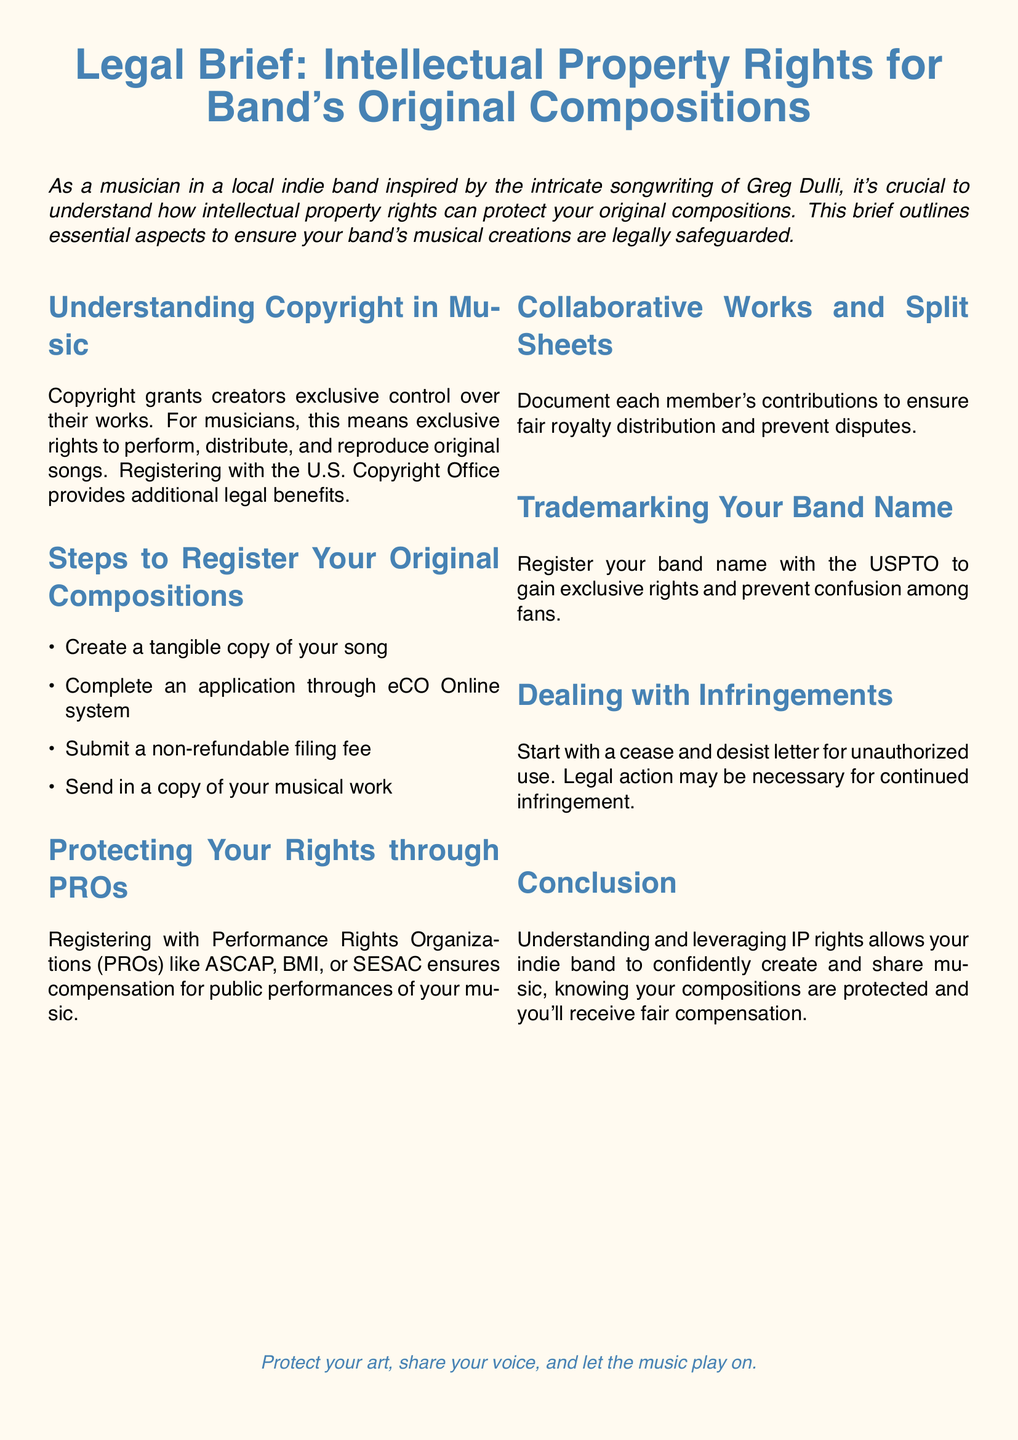What is the title of the legal brief? The title is the main heading of the document and indicates the subject matter.
Answer: Legal Brief: Intellectual Property Rights for Band's Original Compositions What is the first step to register your original compositions? The first step listed under the registration process outlines the initial requirement for registration.
Answer: Create a tangible copy of your song Which organization ensures compensation for public performances? This reference points to entities designed to manage performance rights for musicians.
Answer: PROs What should you document to ensure fair royalty distribution? This question addresses how to ensure clarity and fairness in collaborations among band members.
Answer: Split Sheets What type of letter should be sent for unauthorized use? This question asks for the legal correspondence recommended to address copyright infringement.
Answer: Cease and desist letter Which office should you register your band name with? This question identifies the specific office responsible for trademarking band names legally.
Answer: USPTO How many steps are listed in the registration process? This counts the number of listed actions required for registering original compositions.
Answer: Four What is the primary benefit of registering with the U.S. Copyright Office? This highlights the significant advantage of official registration of musical works.
Answer: Additional legal benefits 